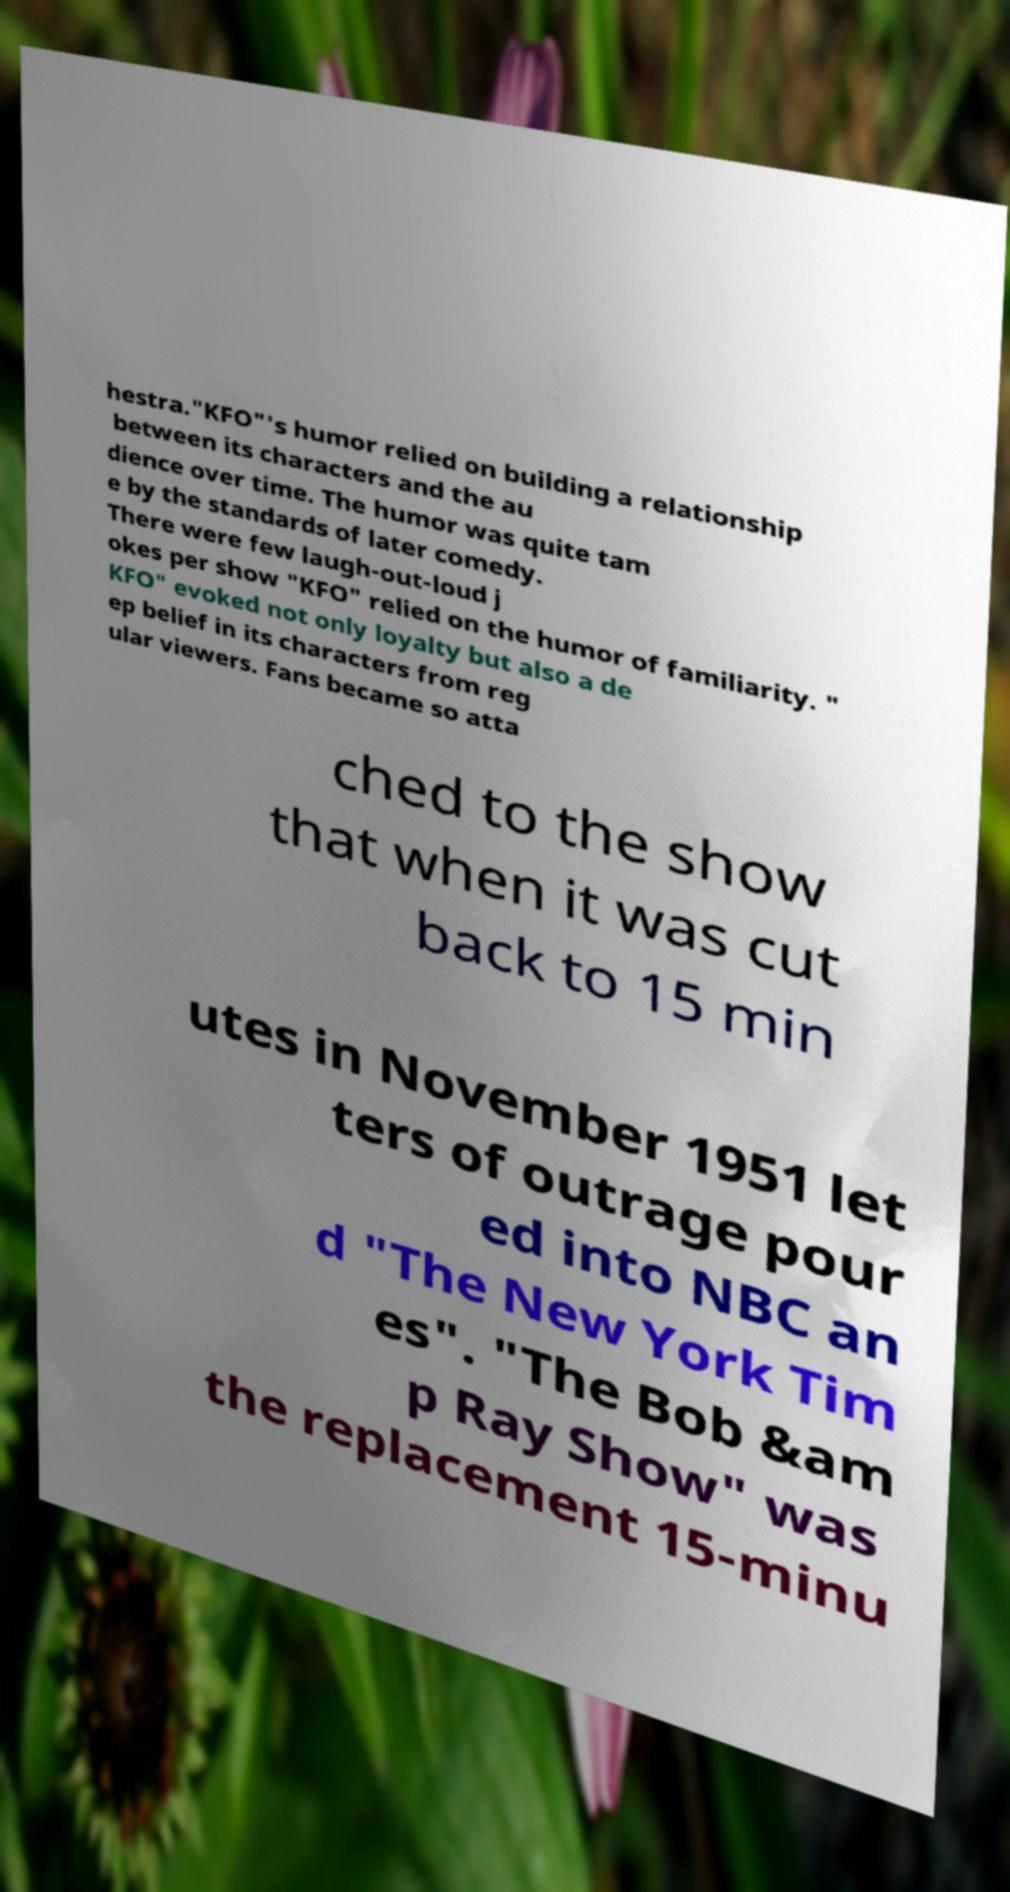Please read and relay the text visible in this image. What does it say? hestra."KFO"'s humor relied on building a relationship between its characters and the au dience over time. The humor was quite tam e by the standards of later comedy. There were few laugh-out-loud j okes per show "KFO" relied on the humor of familiarity. " KFO" evoked not only loyalty but also a de ep belief in its characters from reg ular viewers. Fans became so atta ched to the show that when it was cut back to 15 min utes in November 1951 let ters of outrage pour ed into NBC an d "The New York Tim es". "The Bob &am p Ray Show" was the replacement 15-minu 